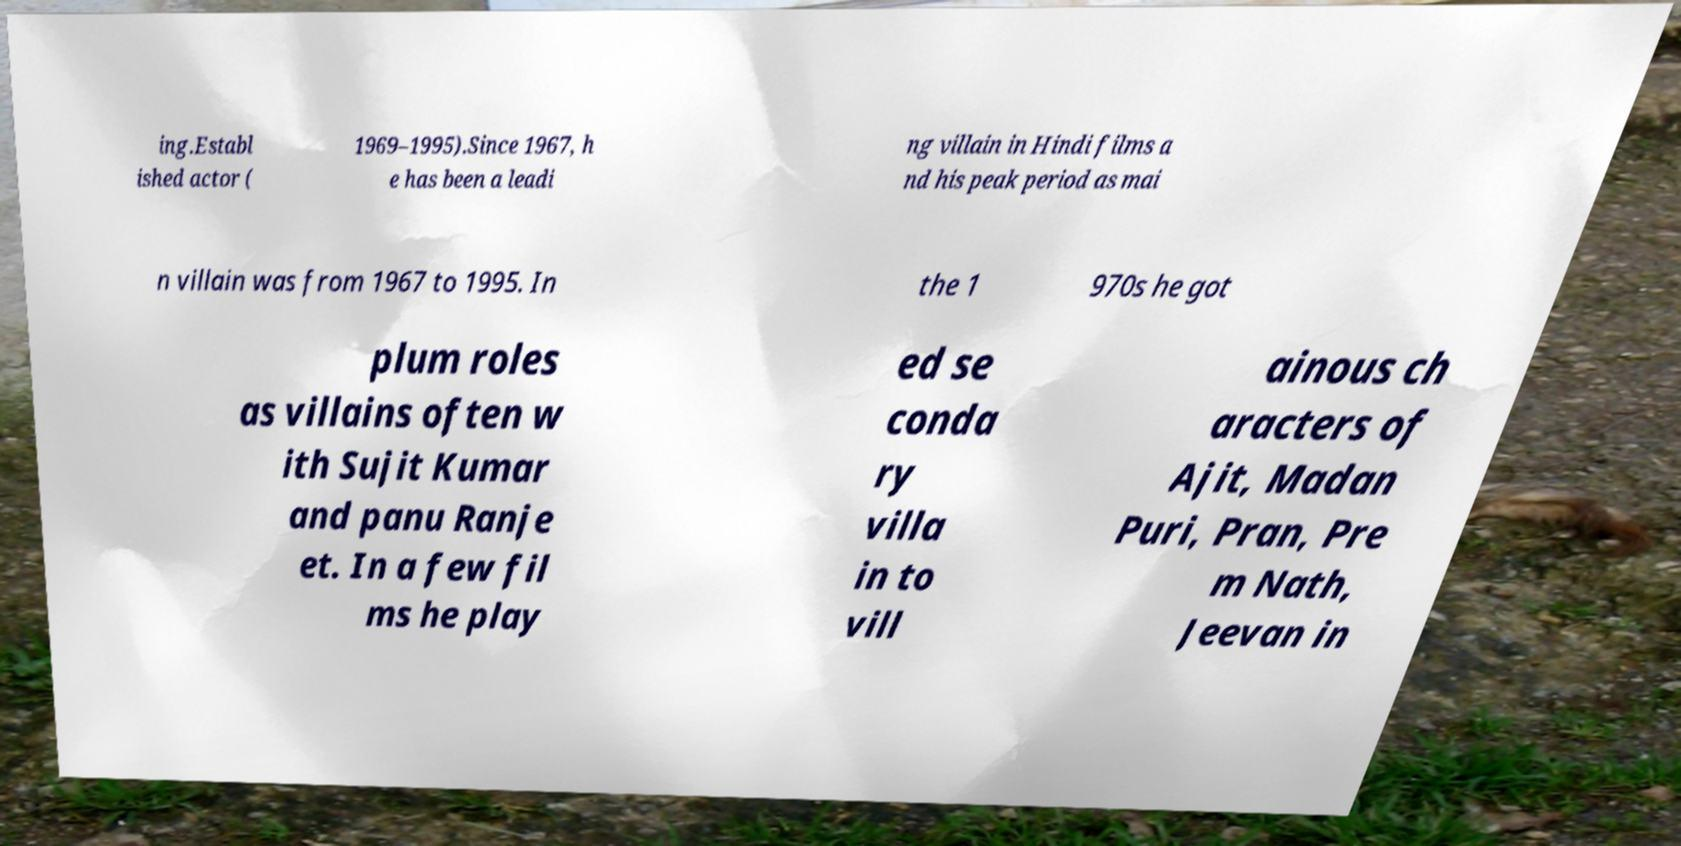Could you assist in decoding the text presented in this image and type it out clearly? ing.Establ ished actor ( 1969–1995).Since 1967, h e has been a leadi ng villain in Hindi films a nd his peak period as mai n villain was from 1967 to 1995. In the 1 970s he got plum roles as villains often w ith Sujit Kumar and panu Ranje et. In a few fil ms he play ed se conda ry villa in to vill ainous ch aracters of Ajit, Madan Puri, Pran, Pre m Nath, Jeevan in 